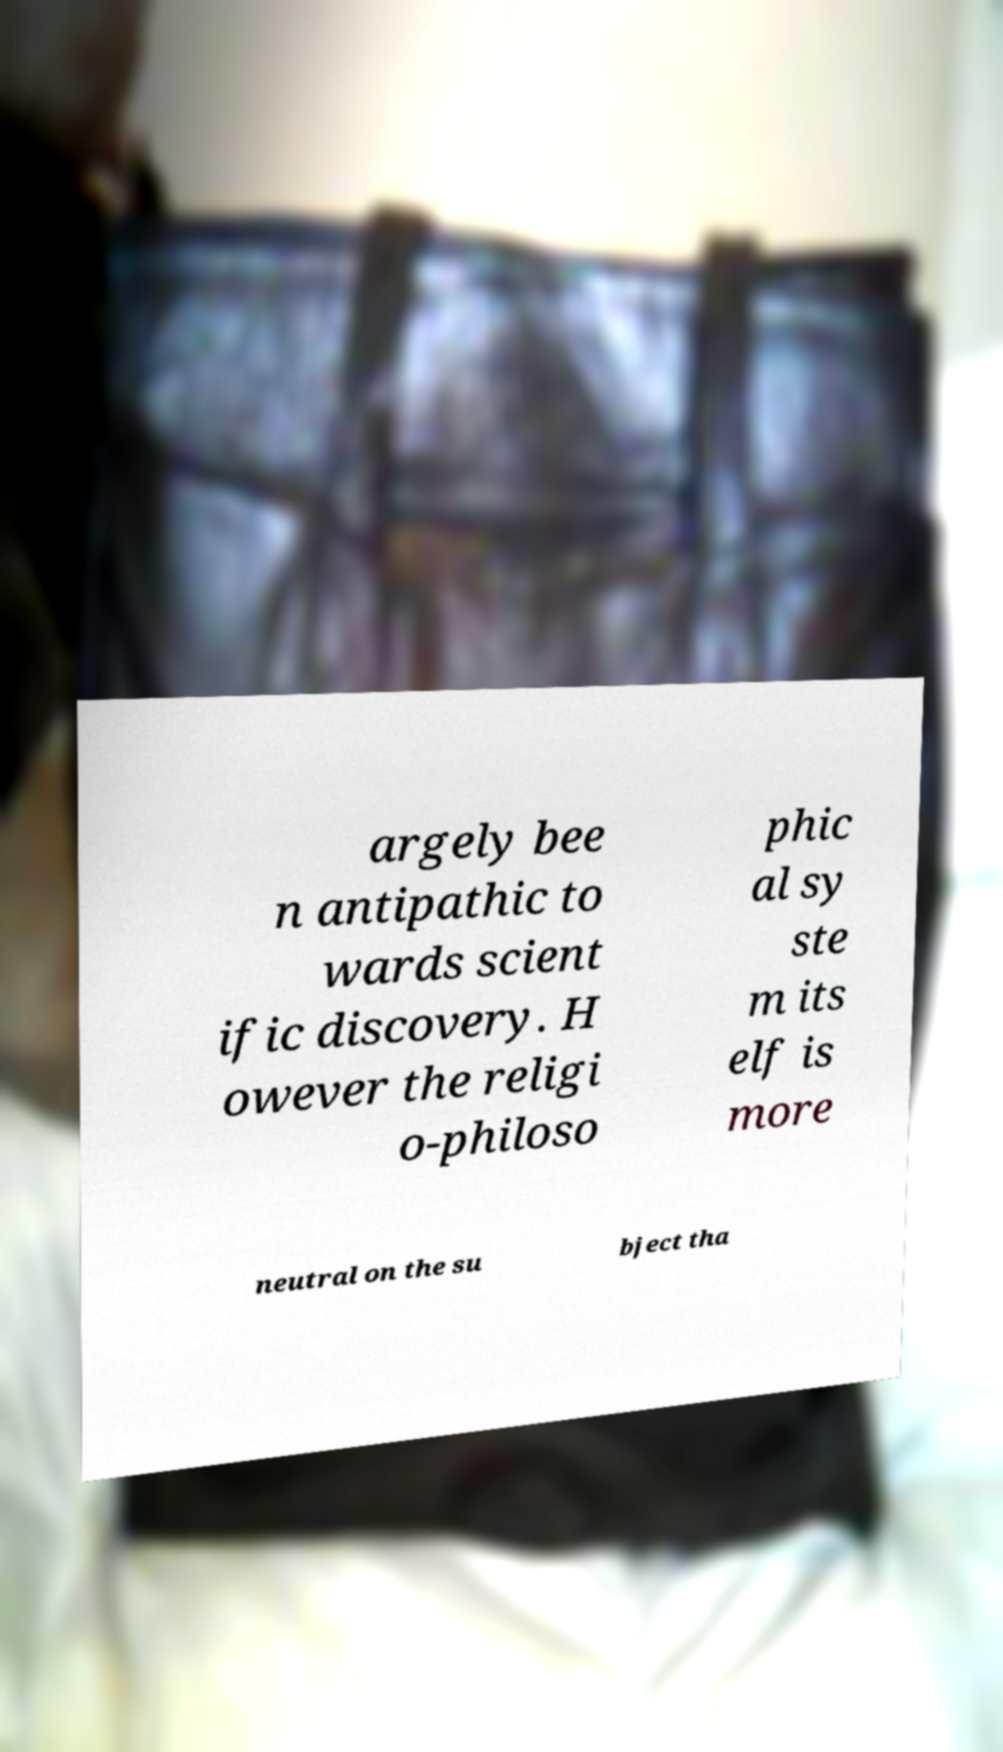Could you assist in decoding the text presented in this image and type it out clearly? argely bee n antipathic to wards scient ific discovery. H owever the religi o-philoso phic al sy ste m its elf is more neutral on the su bject tha 